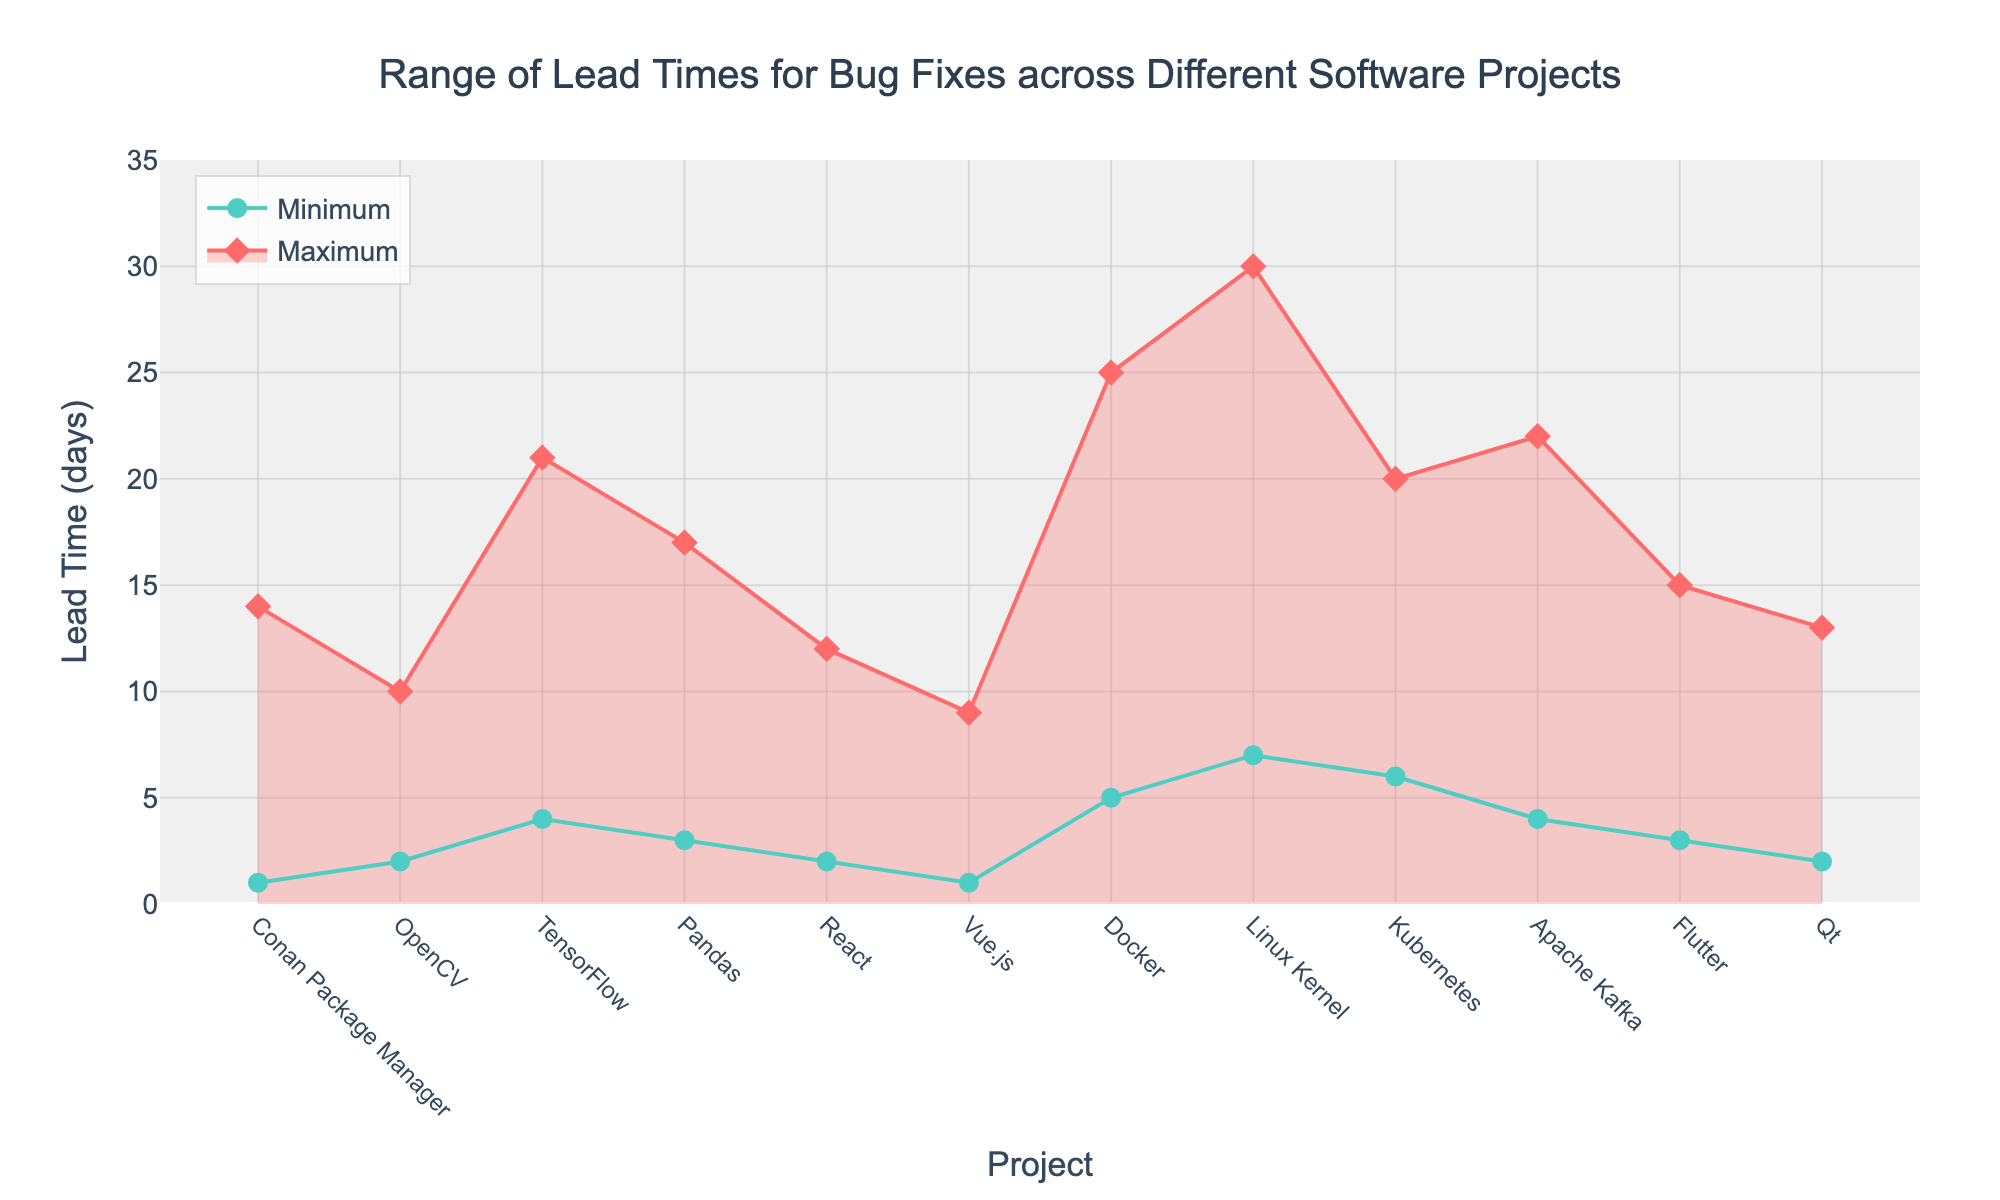What is the project with the shortest minimum lead time for bug fixes? Look at all the minimum lead times and find the smallest value. The shortest minimum lead time is 1 day, which can be found for both the Conan Package Manager and Vue.js projects.
Answer: Conan Package Manager and Vue.js Which project has the longest maximum lead time for bug fixes? Identify the maximum lead time values for all projects and find the greatest one. The longest maximum lead time is 30 days for the Linux Kernel project.
Answer: Linux Kernel What is the range of lead times for the TensorFlow project? The range is calculated as the difference between the maximum and minimum lead times. For TensorFlow, the maximum lead time is 21 days, and the minimum is 4 days. So, the range is 21 - 4 = 17 days.
Answer: 17 days Which projects have a maximum lead time less than 15 days? Check all the maximum lead times and list those projects with a value less than 15. The projects meeting this criterion are Conan Package Manager, OpenCV, React, Vue.js, Flutter, and Qt.
Answer: Conan Package Manager, OpenCV, React, Vue.js, Flutter, and Qt How does the lead time range for Kubernetes compare to that of Docker? Compare the difference between the maximum and minimum lead times of Kubernetes and Docker. For Kubernetes, the range is 20 - 6 = 14 days. For Docker, it is 25 - 5 = 20 days. Kubernetes has a smaller range than Docker.
Answer: Kubernetes has a smaller range than Docker What is the average maximum lead time across all projects? Sum all the maximum lead times and divide by the number of projects. The total sum of maximum lead times is 14 + 10 + 21 + 17 + 12 + 9 + 25 + 30 + 20 + 22 + 15 + 13 = 208. There are 12 projects, so the average is 208 / 12 ≈ 17.33 days.
Answer: 17.33 days Which project shows the narrowest range between the minimum and maximum lead times? Calculate the range for each project by subtracting the minimum lead time from the maximum lead time, and find the smallest range. The narrowest range is for OpenCV, which has a range of 10 - 2 = 8 days.
Answer: OpenCV What is the difference in maximum lead times between Apache Kafka and React? Subtract the maximum lead time of React from that of Apache Kafka. Apache Kafka has a maximum lead time of 22 days, and React has 12 days. So, 22 - 12 = 10 days.
Answer: 10 days Do any projects have identical minimum lead times? If so, which ones? Check if any projects share the same minimum lead time value. Conan Package Manager and Vue.js both have a minimum lead time of 1 day.
Answer: Conan Package Manager and Vue.js What is the difference between the minimum lead times of Pandas and Linux Kernel? Subtract the minimum lead time of Pandas from that of Linux Kernel. The minimum lead time for Pandas is 3 days, and for Linux Kernel, it is 7 days. So, 7 - 3 = 4 days.
Answer: 4 days 